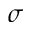Convert formula to latex. <formula><loc_0><loc_0><loc_500><loc_500>\sigma</formula> 